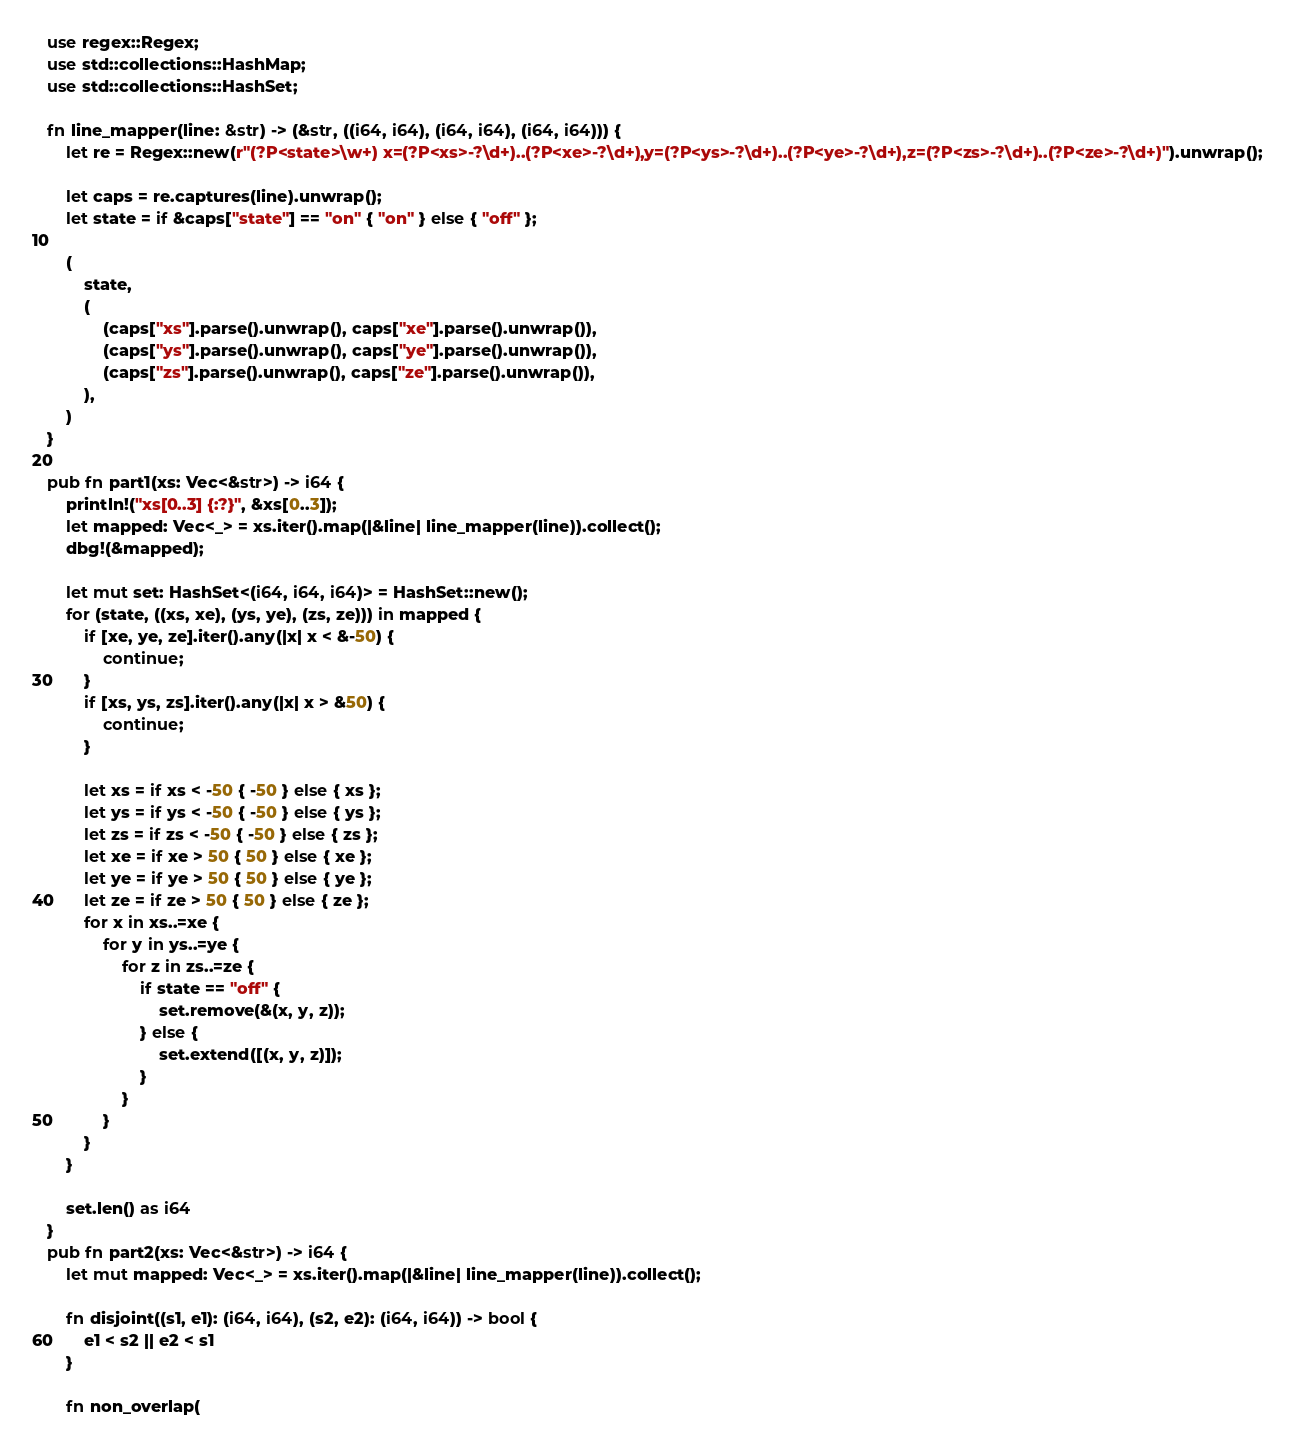Convert code to text. <code><loc_0><loc_0><loc_500><loc_500><_Rust_>use regex::Regex;
use std::collections::HashMap;
use std::collections::HashSet;

fn line_mapper(line: &str) -> (&str, ((i64, i64), (i64, i64), (i64, i64))) {
    let re = Regex::new(r"(?P<state>\w+) x=(?P<xs>-?\d+)..(?P<xe>-?\d+),y=(?P<ys>-?\d+)..(?P<ye>-?\d+),z=(?P<zs>-?\d+)..(?P<ze>-?\d+)").unwrap();

    let caps = re.captures(line).unwrap();
    let state = if &caps["state"] == "on" { "on" } else { "off" };

    (
        state,
        (
            (caps["xs"].parse().unwrap(), caps["xe"].parse().unwrap()),
            (caps["ys"].parse().unwrap(), caps["ye"].parse().unwrap()),
            (caps["zs"].parse().unwrap(), caps["ze"].parse().unwrap()),
        ),
    )
}

pub fn part1(xs: Vec<&str>) -> i64 {
    println!("xs[0..3] {:?}", &xs[0..3]);
    let mapped: Vec<_> = xs.iter().map(|&line| line_mapper(line)).collect();
    dbg!(&mapped);

    let mut set: HashSet<(i64, i64, i64)> = HashSet::new();
    for (state, ((xs, xe), (ys, ye), (zs, ze))) in mapped {
        if [xe, ye, ze].iter().any(|x| x < &-50) {
            continue;
        }
        if [xs, ys, zs].iter().any(|x| x > &50) {
            continue;
        }

        let xs = if xs < -50 { -50 } else { xs };
        let ys = if ys < -50 { -50 } else { ys };
        let zs = if zs < -50 { -50 } else { zs };
        let xe = if xe > 50 { 50 } else { xe };
        let ye = if ye > 50 { 50 } else { ye };
        let ze = if ze > 50 { 50 } else { ze };
        for x in xs..=xe {
            for y in ys..=ye {
                for z in zs..=ze {
                    if state == "off" {
                        set.remove(&(x, y, z));
                    } else {
                        set.extend([(x, y, z)]);
                    }
                }
            }
        }
    }

    set.len() as i64
}
pub fn part2(xs: Vec<&str>) -> i64 {
    let mut mapped: Vec<_> = xs.iter().map(|&line| line_mapper(line)).collect();

    fn disjoint((s1, e1): (i64, i64), (s2, e2): (i64, i64)) -> bool {
        e1 < s2 || e2 < s1
    }

    fn non_overlap(</code> 